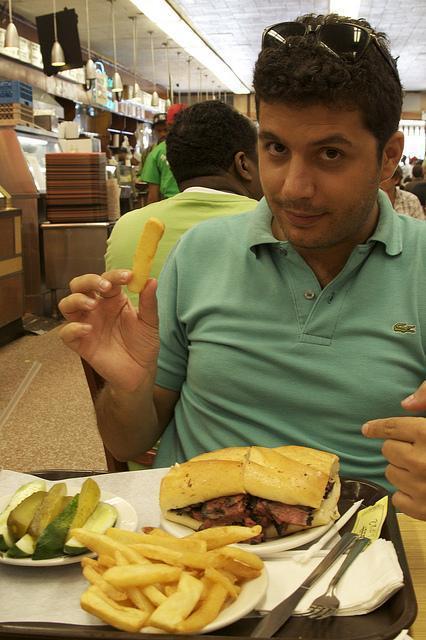How many people are there?
Give a very brief answer. 2. 